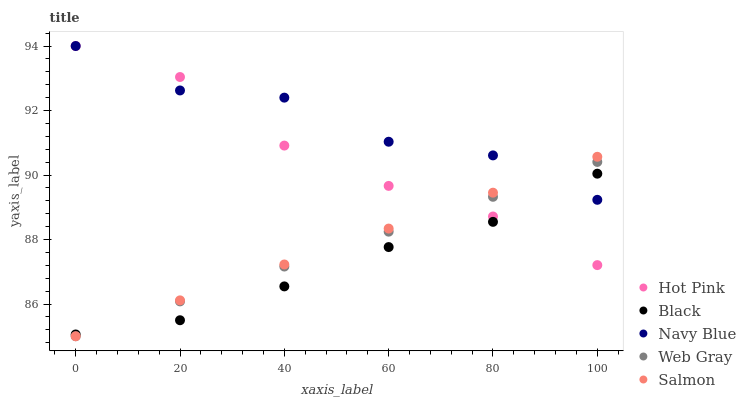Does Black have the minimum area under the curve?
Answer yes or no. Yes. Does Navy Blue have the maximum area under the curve?
Answer yes or no. Yes. Does Hot Pink have the minimum area under the curve?
Answer yes or no. No. Does Hot Pink have the maximum area under the curve?
Answer yes or no. No. Is Salmon the smoothest?
Answer yes or no. Yes. Is Navy Blue the roughest?
Answer yes or no. Yes. Is Hot Pink the smoothest?
Answer yes or no. No. Is Hot Pink the roughest?
Answer yes or no. No. Does Web Gray have the lowest value?
Answer yes or no. Yes. Does Hot Pink have the lowest value?
Answer yes or no. No. Does Hot Pink have the highest value?
Answer yes or no. Yes. Does Black have the highest value?
Answer yes or no. No. Does Web Gray intersect Salmon?
Answer yes or no. Yes. Is Web Gray less than Salmon?
Answer yes or no. No. Is Web Gray greater than Salmon?
Answer yes or no. No. 